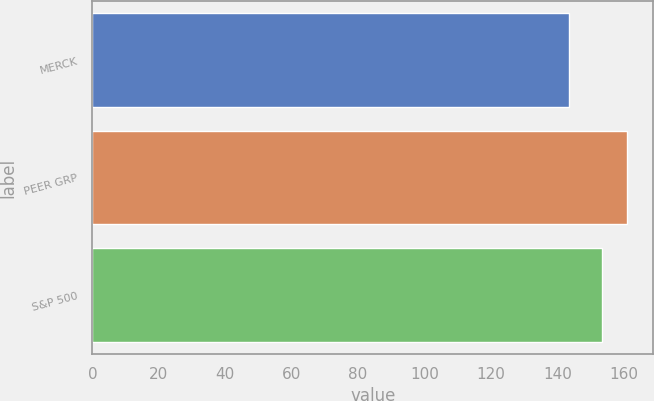<chart> <loc_0><loc_0><loc_500><loc_500><bar_chart><fcel>MERCK<fcel>PEER GRP<fcel>S&P 500<nl><fcel>143.42<fcel>160.92<fcel>153.55<nl></chart> 